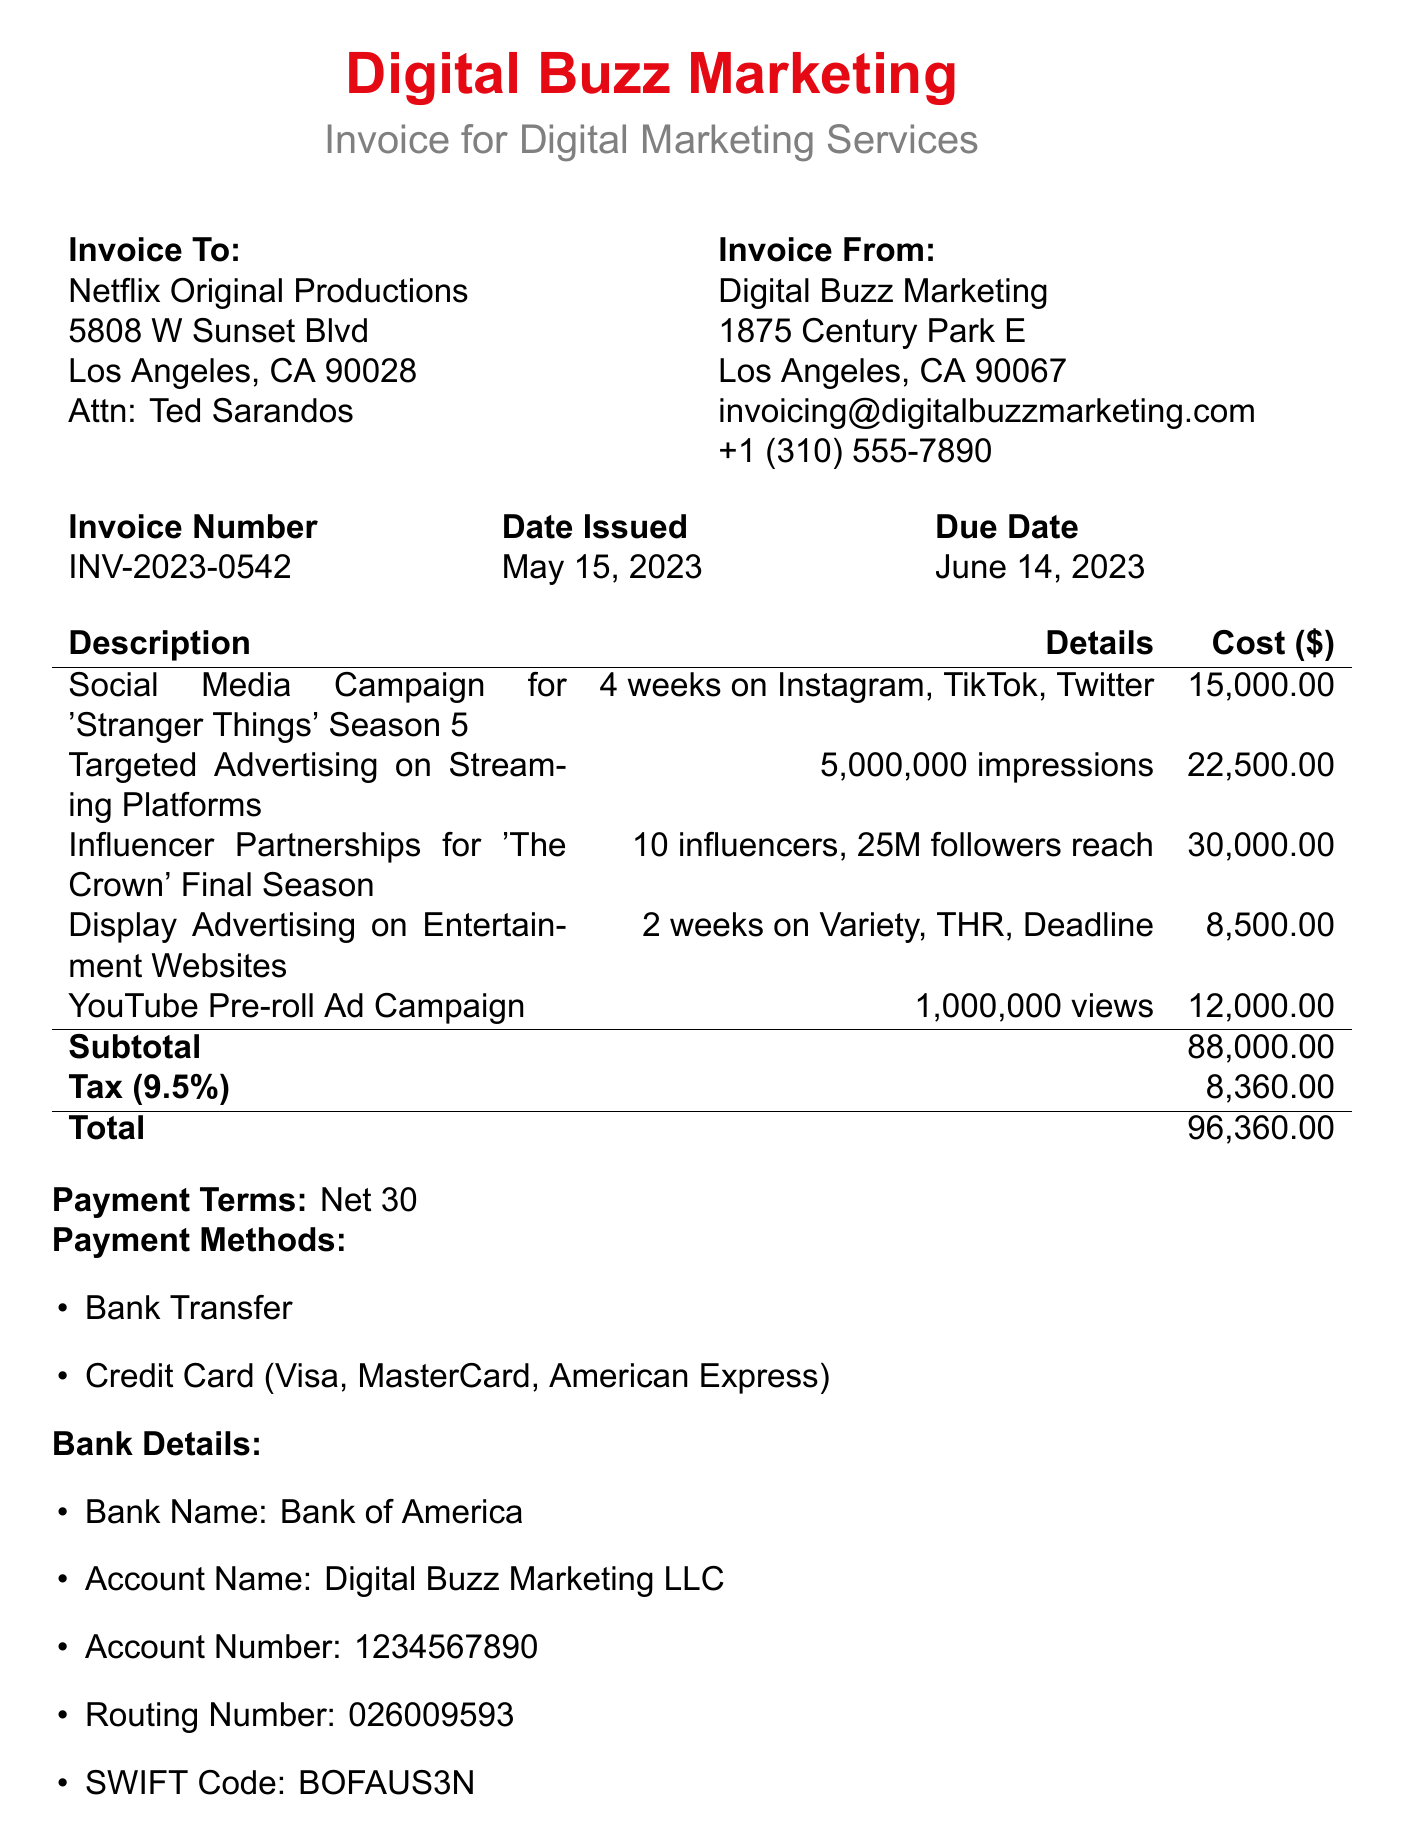What is the invoice number? The invoice number is clearly stated in the document, helping to identify this specific transaction.
Answer: INV-2023-0542 Who is the contact person for the client? The contact person's name is mentioned in the client details section of the document.
Answer: Ted Sarandos What is the total amount due? The total amount is calculated at the end of the invoice, summarizing the total cost with taxes included.
Answer: 96,360.00 Which service had the highest cost? By comparing the costs of all services, the one with the highest cost can be identified.
Answer: Influencer Partnerships for 'The Crown' Final Season What is the due date for the invoice payment? The due date is provided to ensure timely payment and is important for financial tracking.
Answer: June 14, 2023 What percentage is the tax rate? The tax rate is explicitly mentioned in the invoice, contributing to the total amount calculations.
Answer: 9.5% How long was the social media campaign for 'Stranger Things'? The duration is specified in the service description for the social media campaign.
Answer: 4 weeks What payment methods are accepted? The document lists acceptable payment methods, which is important for clients to know when settling invoices.
Answer: Bank Transfer, Credit Card (Visa, MasterCard, American Express) 